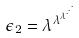Convert formula to latex. <formula><loc_0><loc_0><loc_500><loc_500>\epsilon _ { 2 } = \lambda ^ { \lambda ^ { \lambda ^ { \cdot ^ { \cdot ^ { \cdot } } } } }</formula> 